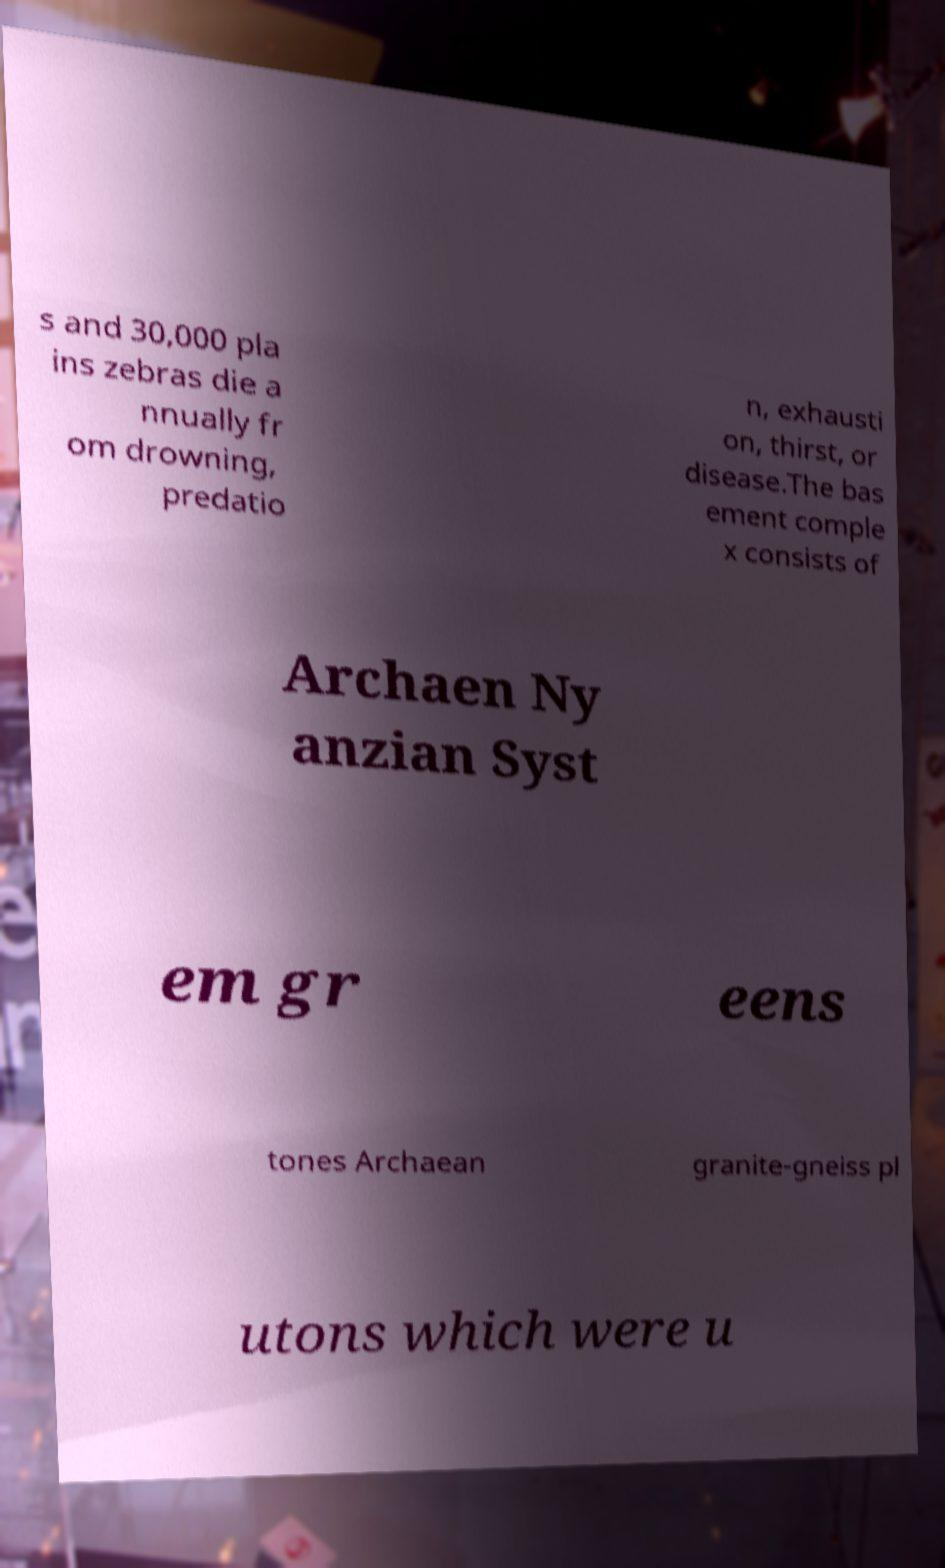Please identify and transcribe the text found in this image. s and 30,000 pla ins zebras die a nnually fr om drowning, predatio n, exhausti on, thirst, or disease.The bas ement comple x consists of Archaen Ny anzian Syst em gr eens tones Archaean granite-gneiss pl utons which were u 